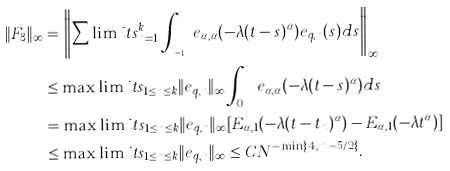<formula> <loc_0><loc_0><loc_500><loc_500>\| F _ { 3 } \| _ { \infty } & = \left \| \sum \lim i t s _ { n = 1 } ^ { k } \int _ { t _ { n - 1 } } ^ { t _ { n } } e _ { \alpha , \alpha } ( - \lambda ( t - s ) ^ { \alpha } ) e _ { q , n } ( s ) d s \right \| _ { \infty } \\ & \leq \max \lim i t s _ { 1 \leq n \leq k } \| e _ { q , n } \| _ { \infty } \int _ { 0 } ^ { t _ { k } } e _ { \alpha , \alpha } ( - \lambda ( t - s ) ^ { \alpha } ) d s \\ & = \max \lim i t s _ { 1 \leq n \leq k } \| e _ { q , n } \| _ { \infty } [ E _ { \alpha , 1 } ( - \lambda ( t - t _ { n } ) ^ { \alpha } ) - E _ { \alpha , 1 } ( - \lambda t ^ { \alpha } ) ] \\ & \leq \max \lim i t s _ { 1 \leq n \leq k } \| e _ { q , n } \| _ { \infty } \leq C N ^ { - \min \{ 4 , m - 5 / 2 \} } .</formula> 